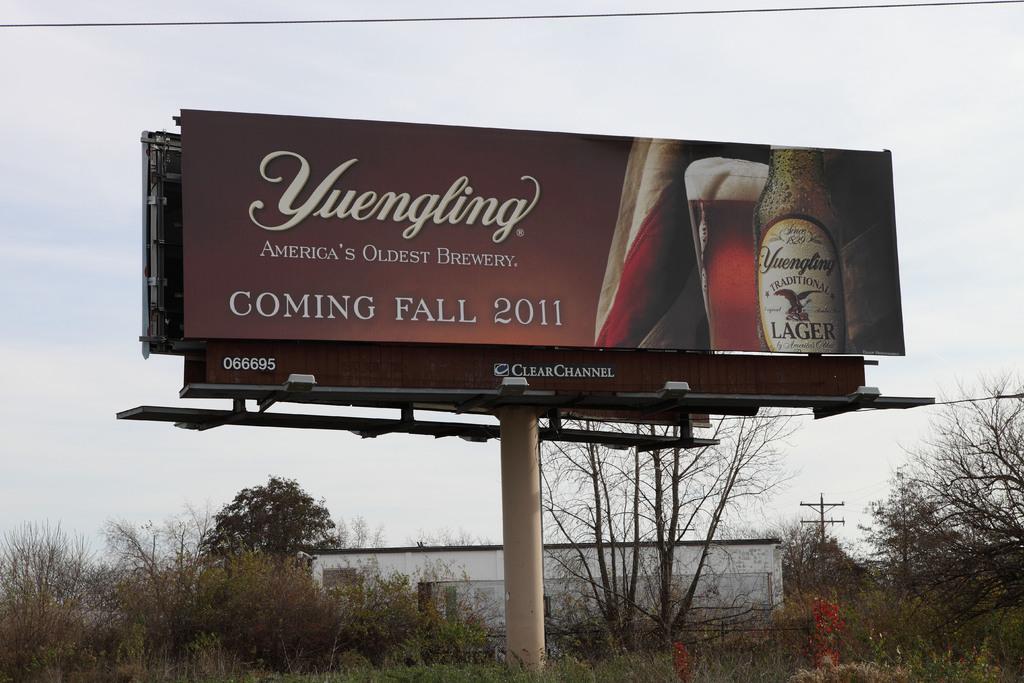What is the brand of beer?
Keep it short and to the point. Yuengling. 